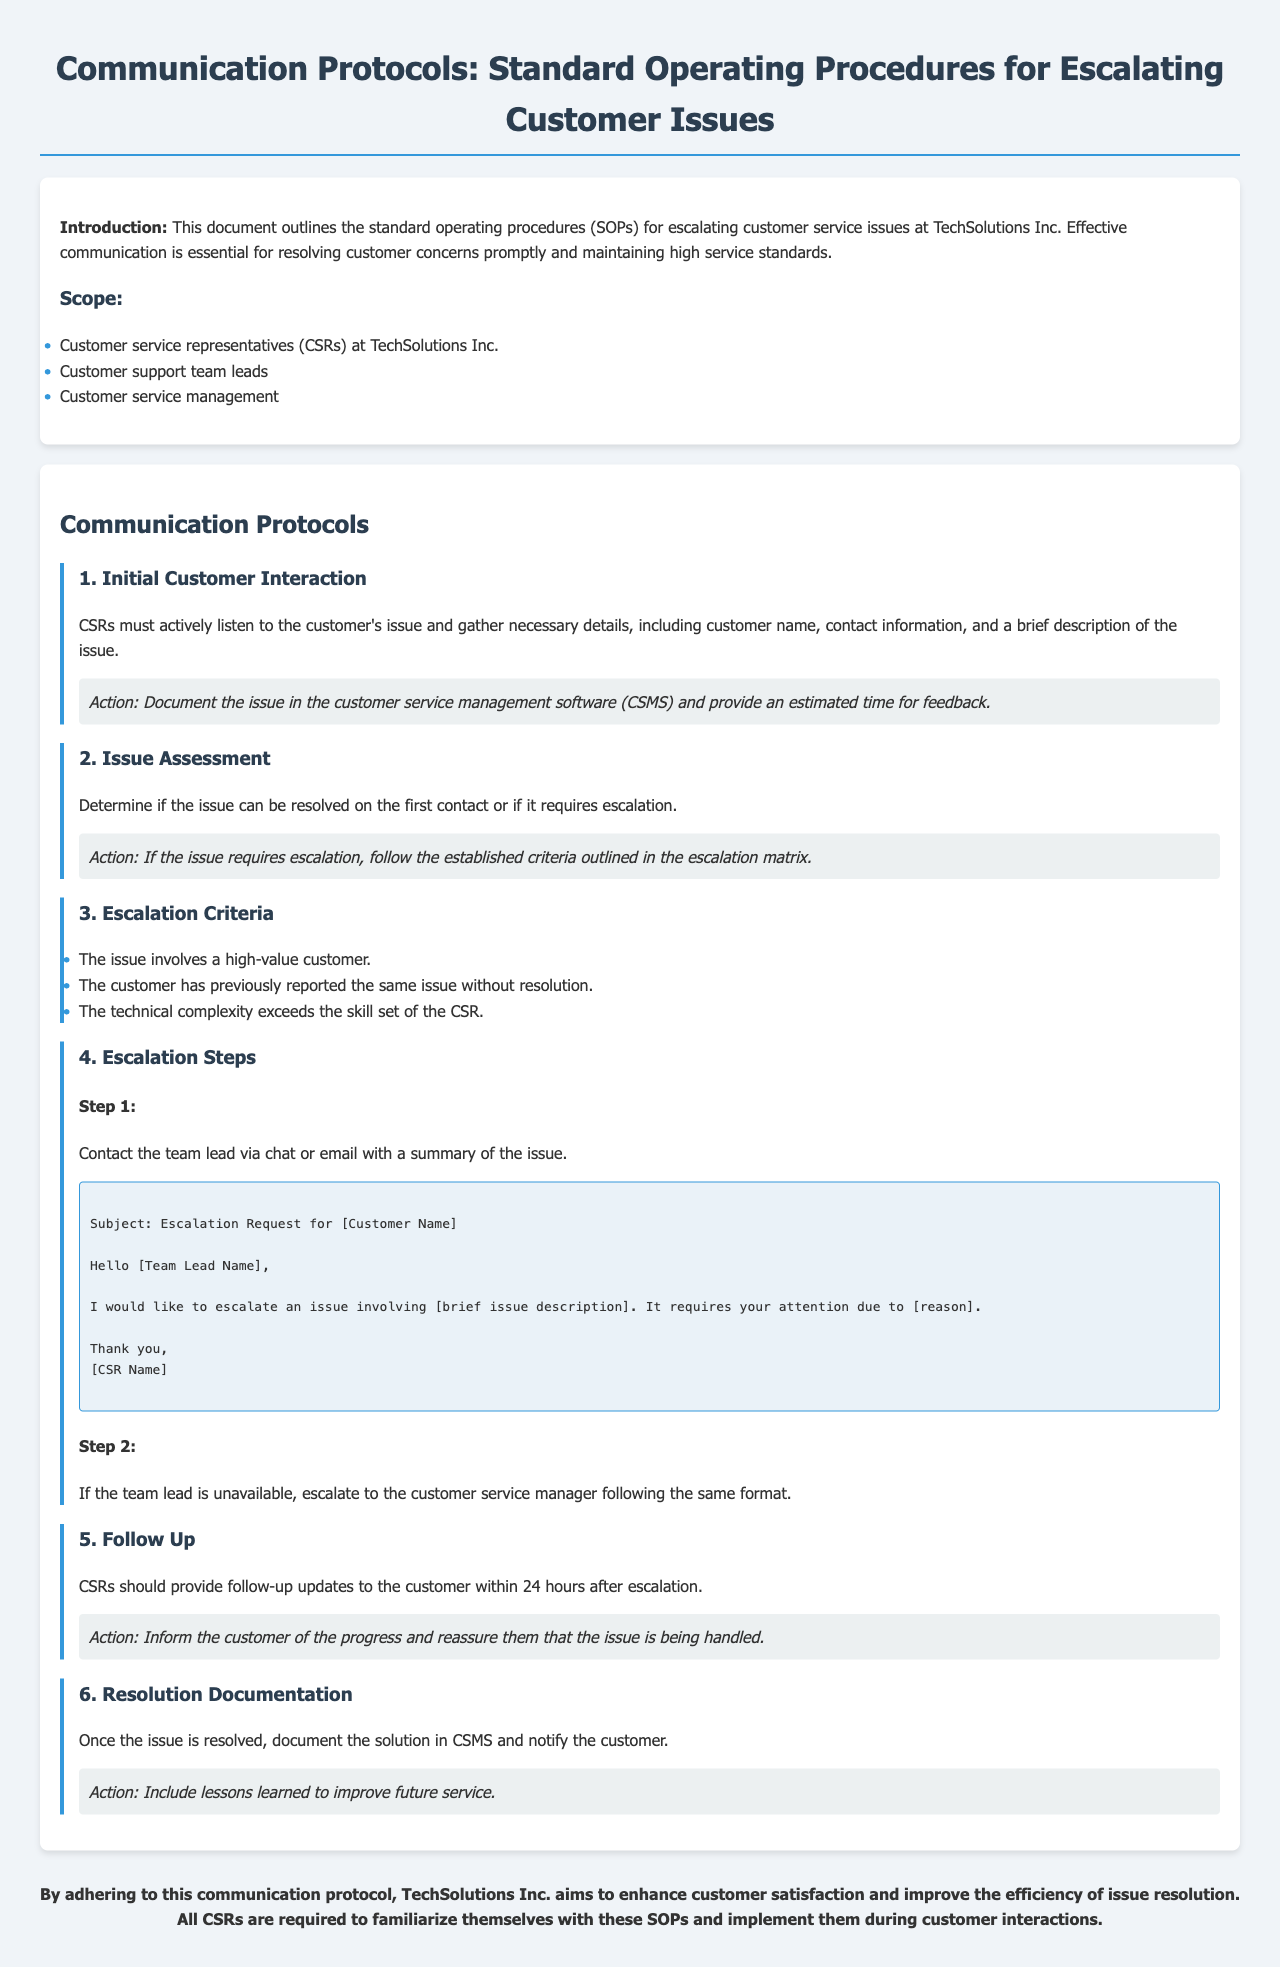what is the title of the document? The title clearly stated at the top of the document is the main subject which is "Communication Protocols: Standard Operating Procedures for Escalating Customer Issues."
Answer: Communication Protocols: Standard Operating Procedures for Escalating Customer Issues who is the intended audience of this manual? The manual specifies the audience in the Scope section, which includes customer service representatives, team leads, and management.
Answer: Customer service representatives, customer support team leads, customer service management what is the first step in the escalation process? The first step involves contacting the team lead via chat or email with a summary of the issue, as outlined in the Escalation Steps.
Answer: Contact the team lead via chat or email how long should CSRs wait before providing follow-up updates? The Follow Up section mentions that updates should be provided within 24 hours after escalation, indicating the time frame for feedback.
Answer: 24 hours what is one reason to escalate an issue? The criteria for escalation include several factors, among which is that the issue involves a high-value customer.
Answer: High-value customer what should be documented once the issue is resolved? The Resolution Documentation section specifies that the solution should be documented in the customer service management software.
Answer: Document the solution in CSMS how many criteria for escalation are listed in the document? The document explicitly lists three criteria for escalating customer issues, summarizing clear standards for escalation.
Answer: Three criteria what is the purpose of the manual? The purpose is stated in the conclusion, focusing on enhancing customer satisfaction and improving issue resolution efficiency.
Answer: Enhance customer satisfaction and improve the efficiency of issue resolution 